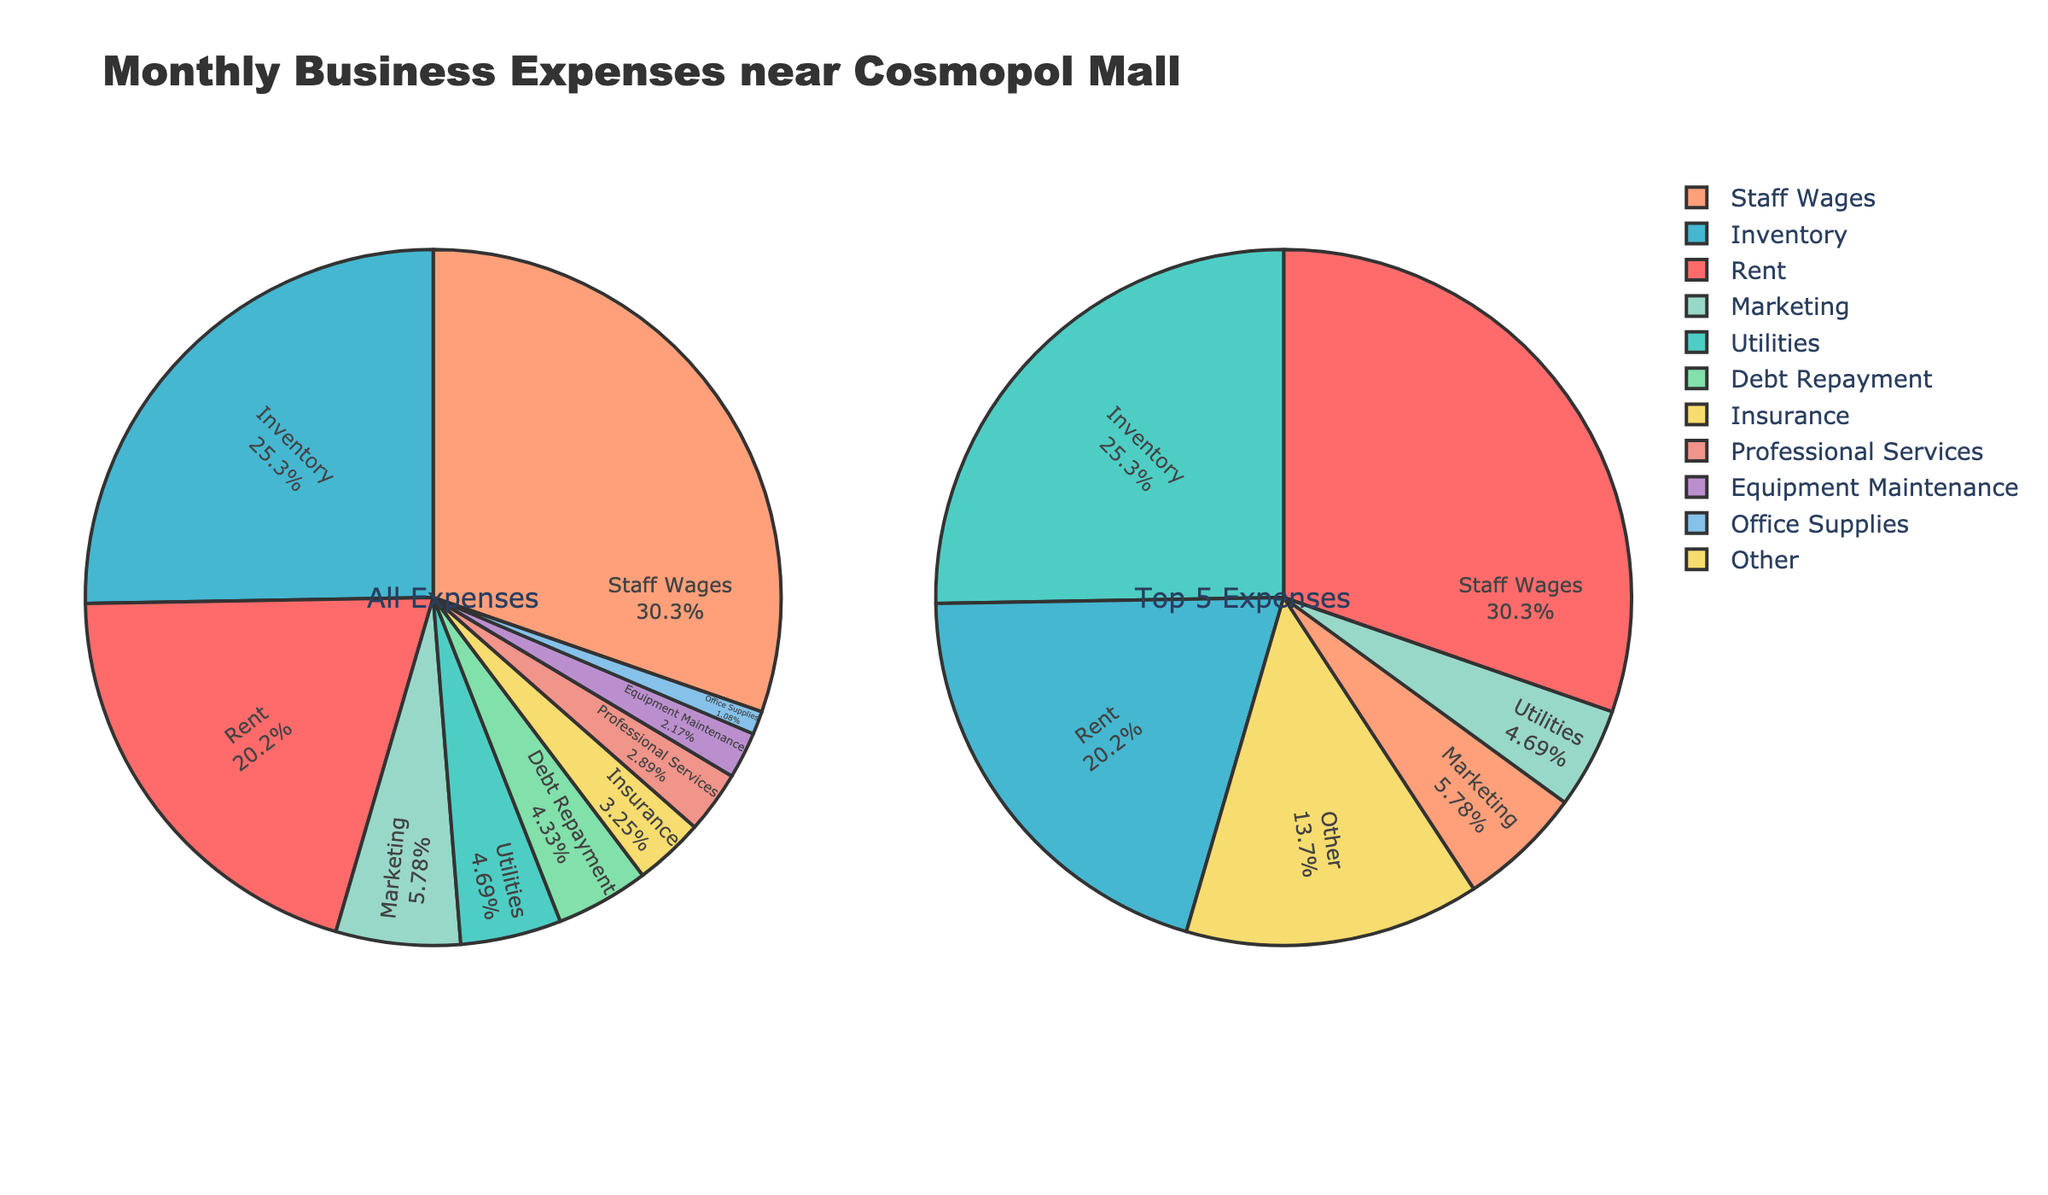1. What is the title of the figure? The title of the figure is located at the top and provides an overview of the content. Here, it is "Monthly Business Expenses near Cosmopol Mall."
Answer: Monthly Business Expenses near Cosmopol Mall 2. Which category has the highest expense in the "All Expenses" pie chart? By observing the "All Expenses" pie chart, we can see that "Staff Wages" occupies the largest portion.
Answer: Staff Wages 3. What percentage of the total expenses is allocated to rent in the "All Expenses" pie chart? The "All Expenses" pie chart shows the percentage distribution of each category. Rent occupies 21%.
Answer: 21% 4. How do the top 5 categories in the "Top 5 Expenses" pie chart compare to the "All Expenses" pie chart? Locate the top 5 categories in the "Top 5 Expenses" pie chart and check if they appear as the largest slices in the "All Expenses" pie chart. The top 5 categories are the same in both charts.
Answer: Same categories 5. What is the total expense for all categories combined? Sum up all the expenses listed in the data provided: 2800 (Rent) + 650 (Utilities) + 3500 (Inventory) + 4200 (Staff Wages) + 800 (Marketing) + 450 (Insurance) + 300 (Equipment Maintenance) + 150 (Office Supplies) + 400 (Professional Services) + 600 (Debt Repayment) = 14850
Answer: 14850 6. How much is spent on categories other than the top 5 in the "Top 5 Expenses" pie chart? To find this, subtract the top 5 expenses from the total expenses. The top 5 categories are Staff Wages, Inventory, Rent, Marketing, and Debt Repayment. Their total is 4200 + 3500 + 2800 + 800 + 600 = 11900. Subtract this from the total 14850 - 11900 = 2950.
Answer: 2950 7. Which expense category has the smallest percentage in the "Top 5 Expenses" pie chart? In the "Top 5 Expenses" pie chart, identify the smallest segment which is "Debt Repayment."
Answer: Debt Repayment 8. What is the difference in allocation between the highest and lowest expense categories in the "All Expenses" pie chart? Identify the highest (Staff Wages: 4200) and lowest (Office Supplies: 150) expenses, and subtract the smallest from the largest: 4200 - 150 = 4050.
Answer: 4050 9. How is the remaining "Other" category calculated in the "Top 5 Expenses" pie chart? The "Other" category is calculated by subtracting the total of the top 5 expenses from the overall total expenses. From the data, sum the expenses of the top 5 categories (Staff Wages, Inventory, Rent, Marketing, Debt Repayment) and subtract from the total: 14850 (total) - 11900 (sum of top 5) = 2950.
Answer: 2950 10. What proportion of the total expenses is represented by utilities and insurance combined? Add the expenses for utilities (650) and insurance (450) then divide by the total expenses. (650 + 450) = 1100. (1100/14850) * 100 = approximately 7.41%.
Answer: 7.41% 